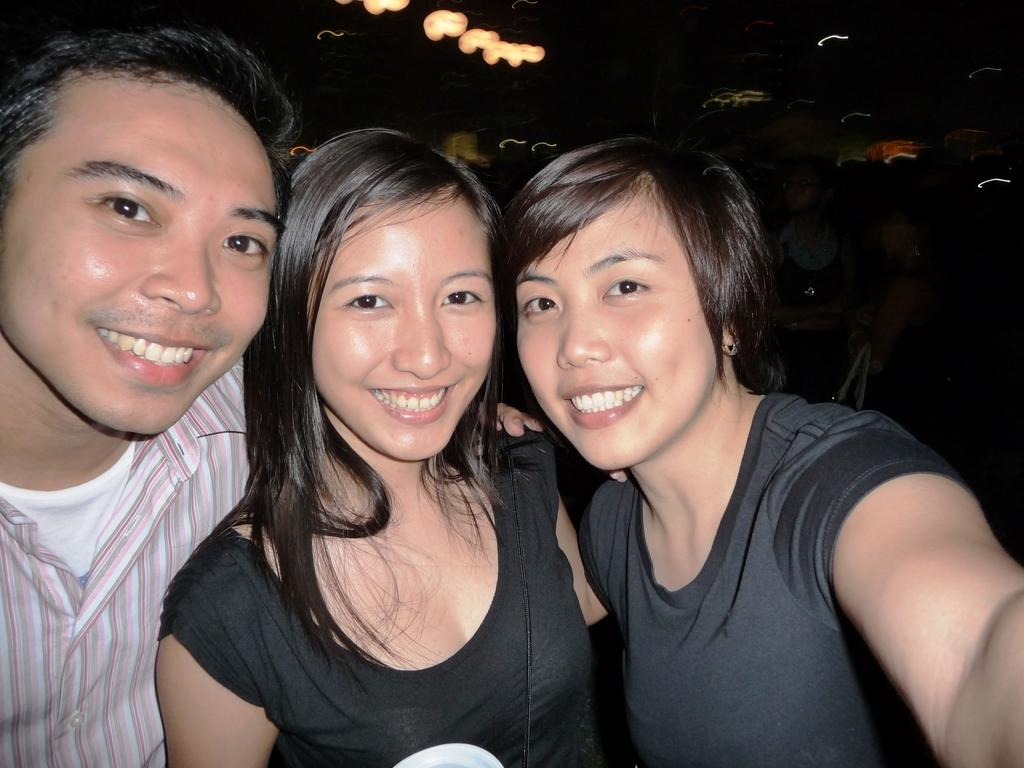How many people are in the image? There are three people in the image: one man and two women. What are the people in the image doing? The man and women are smiling in the image. What can be observed about the background of the image? The background of the image is dark. What type of twig can be seen in the man's hand in the image? There is no twig present in the man's hand or anywhere else in the image. What sound does the voice make in the image? There is no voice or sound present in the image. 